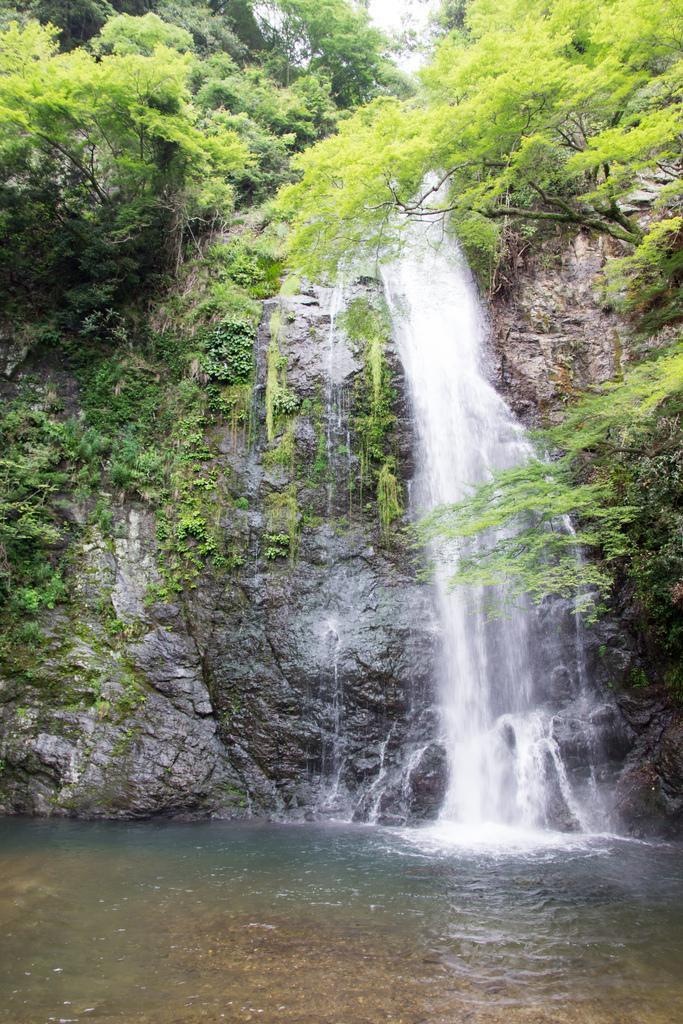Please provide a concise description of this image. In this image we can see some trees, grass and the waterfall. 